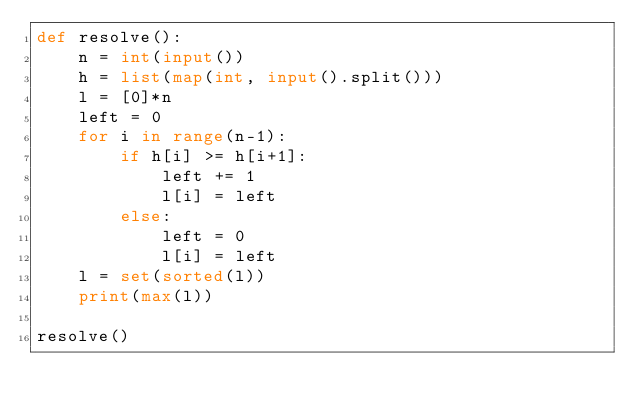<code> <loc_0><loc_0><loc_500><loc_500><_Python_>def resolve():
    n = int(input())
    h = list(map(int, input().split()))
    l = [0]*n
    left = 0
    for i in range(n-1):
        if h[i] >= h[i+1]:
            left += 1
            l[i] = left
        else:
            left = 0
            l[i] = left
    l = set(sorted(l))
    print(max(l))

resolve()</code> 